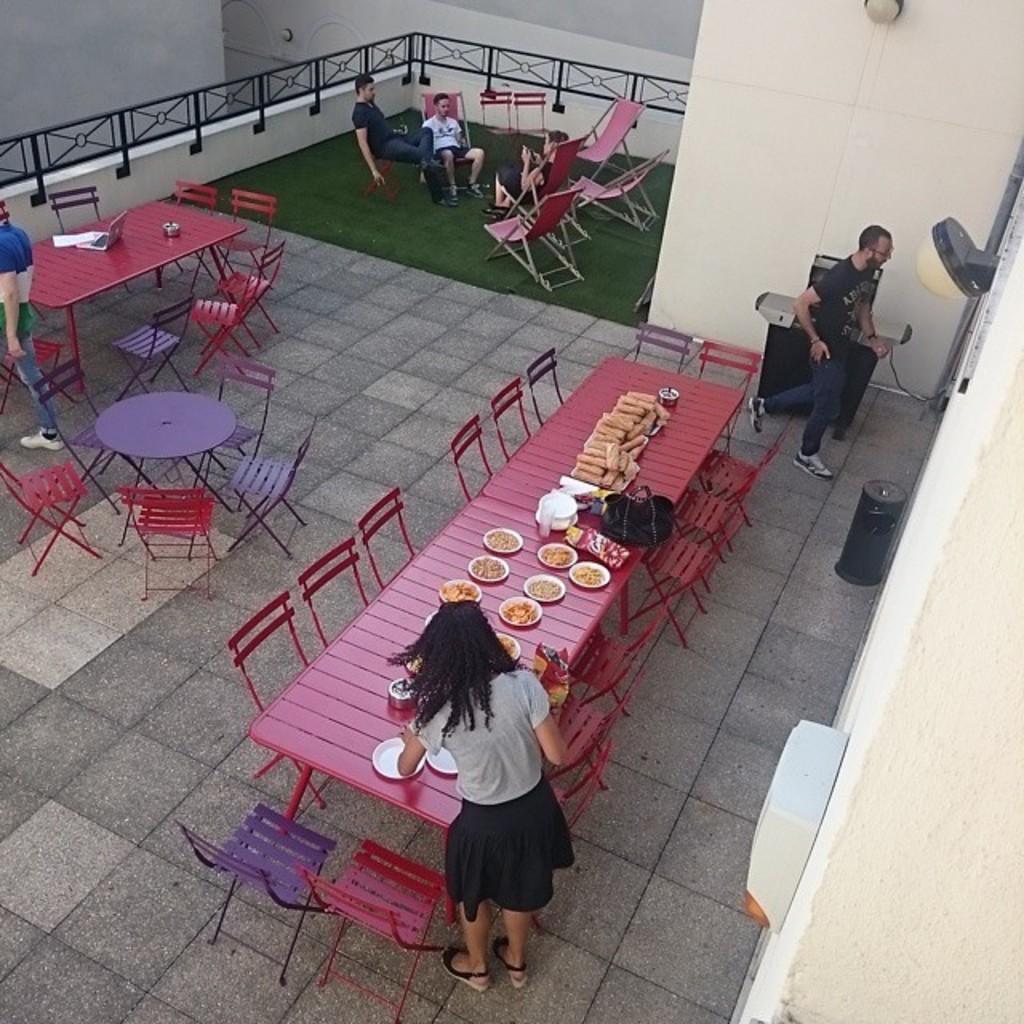Describe this image in one or two sentences. In this picture we can see three persons sitting on the chairs. This is grass. Here we can see some chairs and these are the tables. On the table there are plates, food, bag, and a bowl. And this is bin. Here we can see a wall. 